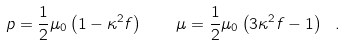Convert formula to latex. <formula><loc_0><loc_0><loc_500><loc_500>p = \frac { 1 } { 2 } \mu _ { 0 } \left ( 1 - \kappa ^ { 2 } f \right ) \quad \mu = \frac { 1 } { 2 } \mu _ { 0 } \left ( 3 \kappa ^ { 2 } f - 1 \right ) \ .</formula> 